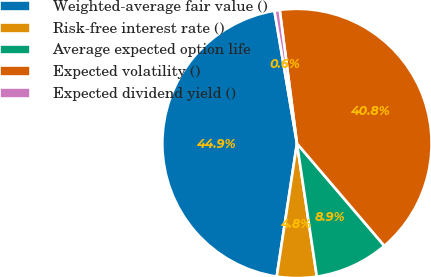Convert chart. <chart><loc_0><loc_0><loc_500><loc_500><pie_chart><fcel>Weighted-average fair value ()<fcel>Risk-free interest rate ()<fcel>Average expected option life<fcel>Expected volatility ()<fcel>Expected dividend yield ()<nl><fcel>44.92%<fcel>4.76%<fcel>8.89%<fcel>40.8%<fcel>0.63%<nl></chart> 